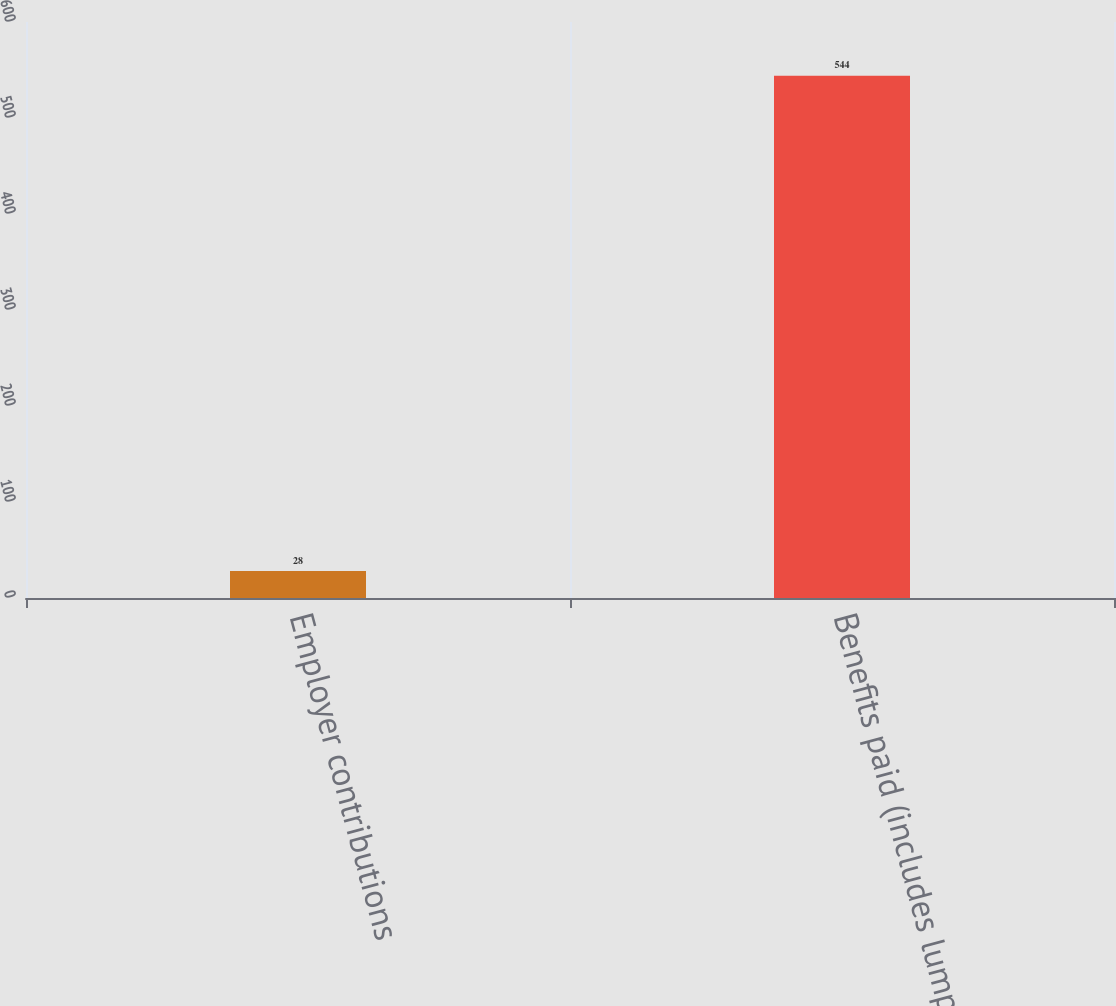Convert chart. <chart><loc_0><loc_0><loc_500><loc_500><bar_chart><fcel>Employer contributions<fcel>Benefits paid (includes lump<nl><fcel>28<fcel>544<nl></chart> 